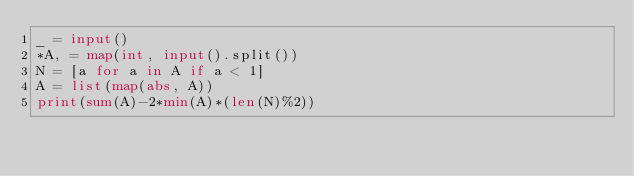Convert code to text. <code><loc_0><loc_0><loc_500><loc_500><_Python_>_ = input()
*A, = map(int, input().split())
N = [a for a in A if a < 1]
A = list(map(abs, A))
print(sum(A)-2*min(A)*(len(N)%2))</code> 